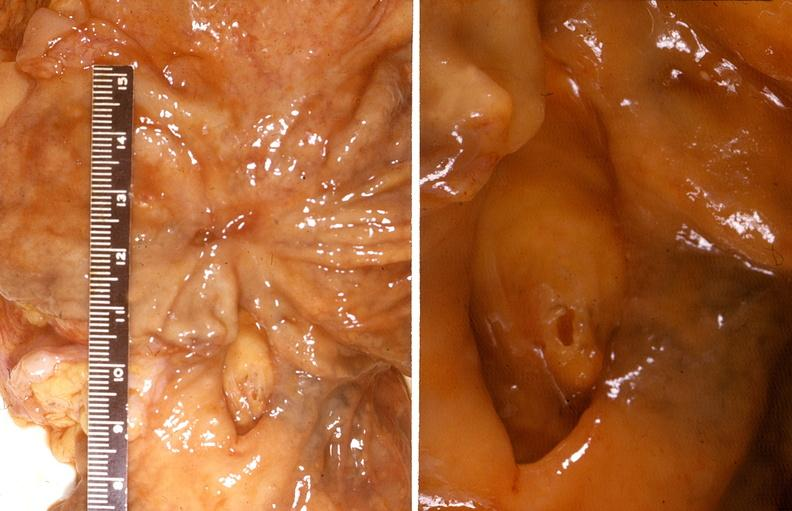s supernumerary digits present?
Answer the question using a single word or phrase. No 